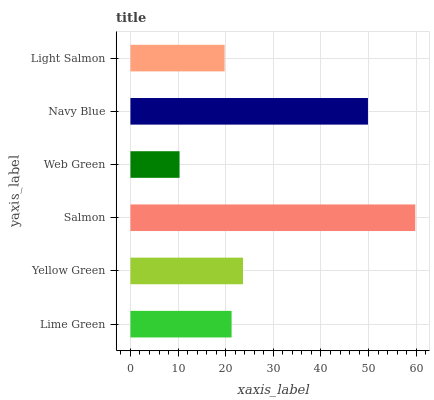Is Web Green the minimum?
Answer yes or no. Yes. Is Salmon the maximum?
Answer yes or no. Yes. Is Yellow Green the minimum?
Answer yes or no. No. Is Yellow Green the maximum?
Answer yes or no. No. Is Yellow Green greater than Lime Green?
Answer yes or no. Yes. Is Lime Green less than Yellow Green?
Answer yes or no. Yes. Is Lime Green greater than Yellow Green?
Answer yes or no. No. Is Yellow Green less than Lime Green?
Answer yes or no. No. Is Yellow Green the high median?
Answer yes or no. Yes. Is Lime Green the low median?
Answer yes or no. Yes. Is Lime Green the high median?
Answer yes or no. No. Is Navy Blue the low median?
Answer yes or no. No. 